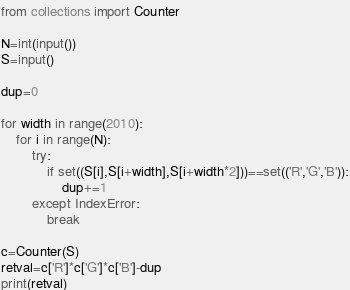Convert code to text. <code><loc_0><loc_0><loc_500><loc_500><_Python_>from collections import Counter

N=int(input())
S=input()

dup=0

for width in range(2010):
    for i in range(N):
        try:
            if set((S[i],S[i+width],S[i+width*2]))==set(('R','G','B')):
                dup+=1
        except IndexError:
            break

c=Counter(S)
retval=c['R']*c['G']*c['B']-dup
print(retval)
</code> 